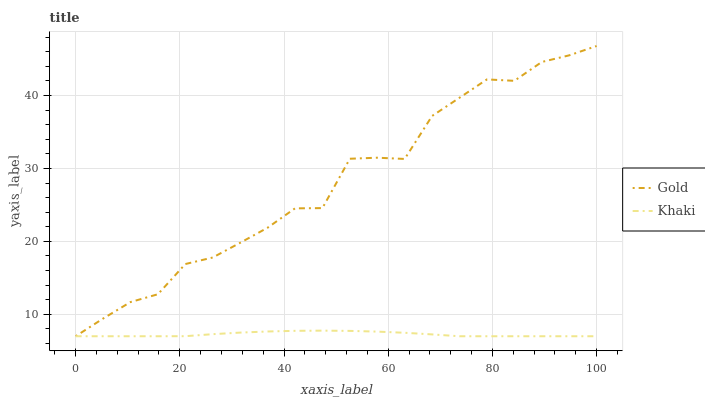Does Gold have the minimum area under the curve?
Answer yes or no. No. Is Gold the smoothest?
Answer yes or no. No. 